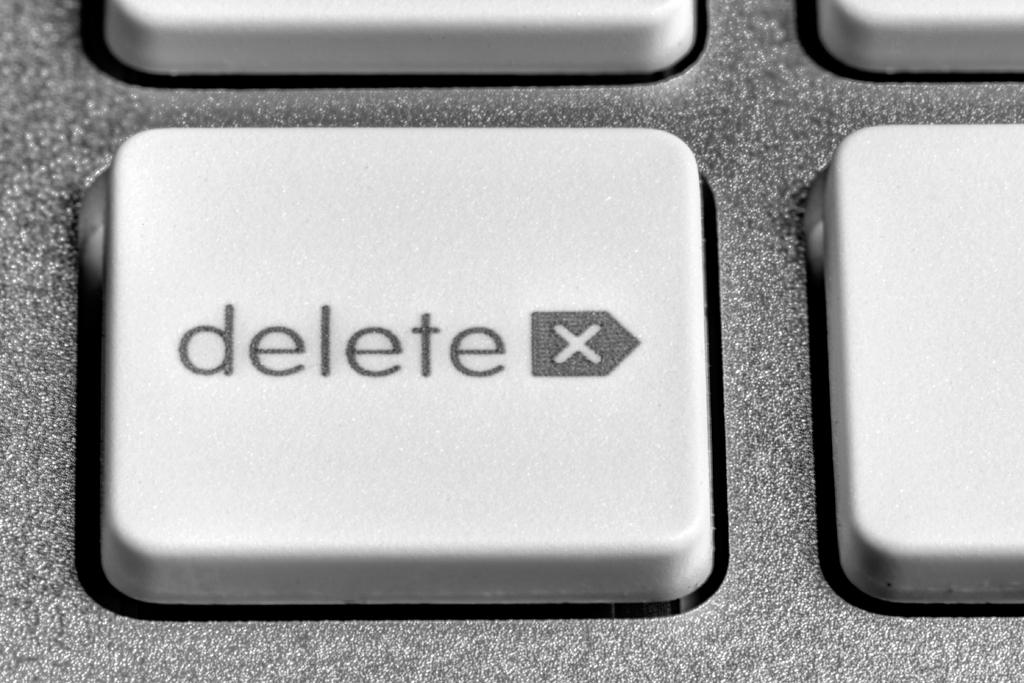<image>
Share a concise interpretation of the image provided. A close up of a delete button on a computer keyboard 